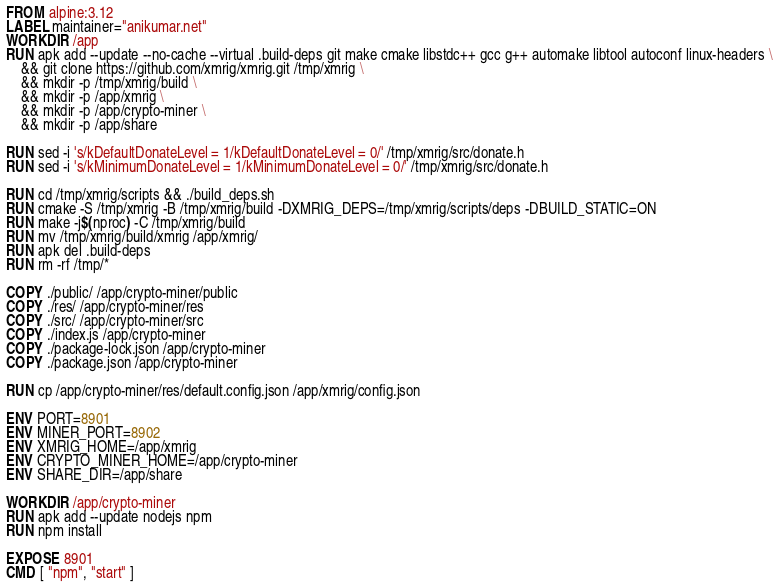Convert code to text. <code><loc_0><loc_0><loc_500><loc_500><_Dockerfile_>FROM alpine:3.12
LABEL maintainer="anikumar.net"
WORKDIR /app
RUN apk add --update --no-cache --virtual .build-deps git make cmake libstdc++ gcc g++ automake libtool autoconf linux-headers \
    && git clone https://github.com/xmrig/xmrig.git /tmp/xmrig \
    && mkdir -p /tmp/xmrig/build \
    && mkdir -p /app/xmrig \
    && mkdir -p /app/crypto-miner \
    && mkdir -p /app/share

RUN sed -i 's/kDefaultDonateLevel = 1/kDefaultDonateLevel = 0/' /tmp/xmrig/src/donate.h
RUN sed -i 's/kMinimumDonateLevel = 1/kMinimumDonateLevel = 0/' /tmp/xmrig/src/donate.h

RUN cd /tmp/xmrig/scripts && ./build_deps.sh
RUN cmake -S /tmp/xmrig -B /tmp/xmrig/build -DXMRIG_DEPS=/tmp/xmrig/scripts/deps -DBUILD_STATIC=ON
RUN make -j$(nproc) -C /tmp/xmrig/build
RUN mv /tmp/xmrig/build/xmrig /app/xmrig/
RUN apk del .build-deps 
RUN rm -rf /tmp/*

COPY ./public/ /app/crypto-miner/public
COPY ./res/ /app/crypto-miner/res
COPY ./src/ /app/crypto-miner/src
COPY ./index.js /app/crypto-miner
COPY ./package-lock.json /app/crypto-miner
COPY ./package.json /app/crypto-miner

RUN cp /app/crypto-miner/res/default.config.json /app/xmrig/config.json

ENV PORT=8901
ENV MINER_PORT=8902
ENV XMRIG_HOME=/app/xmrig
ENV CRYPTO_MINER_HOME=/app/crypto-miner
ENV SHARE_DIR=/app/share 

WORKDIR /app/crypto-miner
RUN apk add --update nodejs npm
RUN npm install

EXPOSE 8901
CMD [ "npm", "start" ]
</code> 